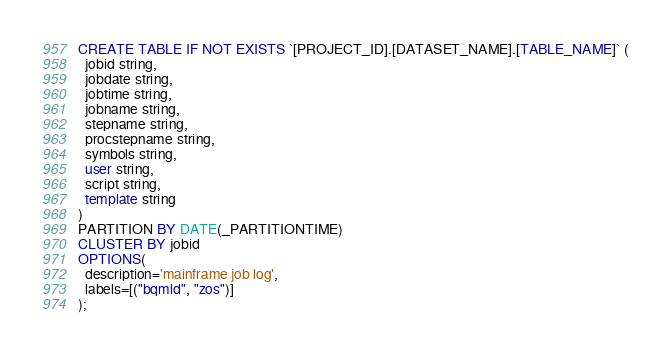<code> <loc_0><loc_0><loc_500><loc_500><_SQL_>CREATE TABLE IF NOT EXISTS `[PROJECT_ID].[DATASET_NAME].[TABLE_NAME]` (
  jobid string,
  jobdate string,
  jobtime string,
  jobname string,
  stepname string,
  procstepname string,
  symbols string,
  user string,
  script string,
  template string
)
PARTITION BY DATE(_PARTITIONTIME)
CLUSTER BY jobid
OPTIONS(
  description='mainframe job log',
  labels=[("bqmld", "zos")]
);
</code> 